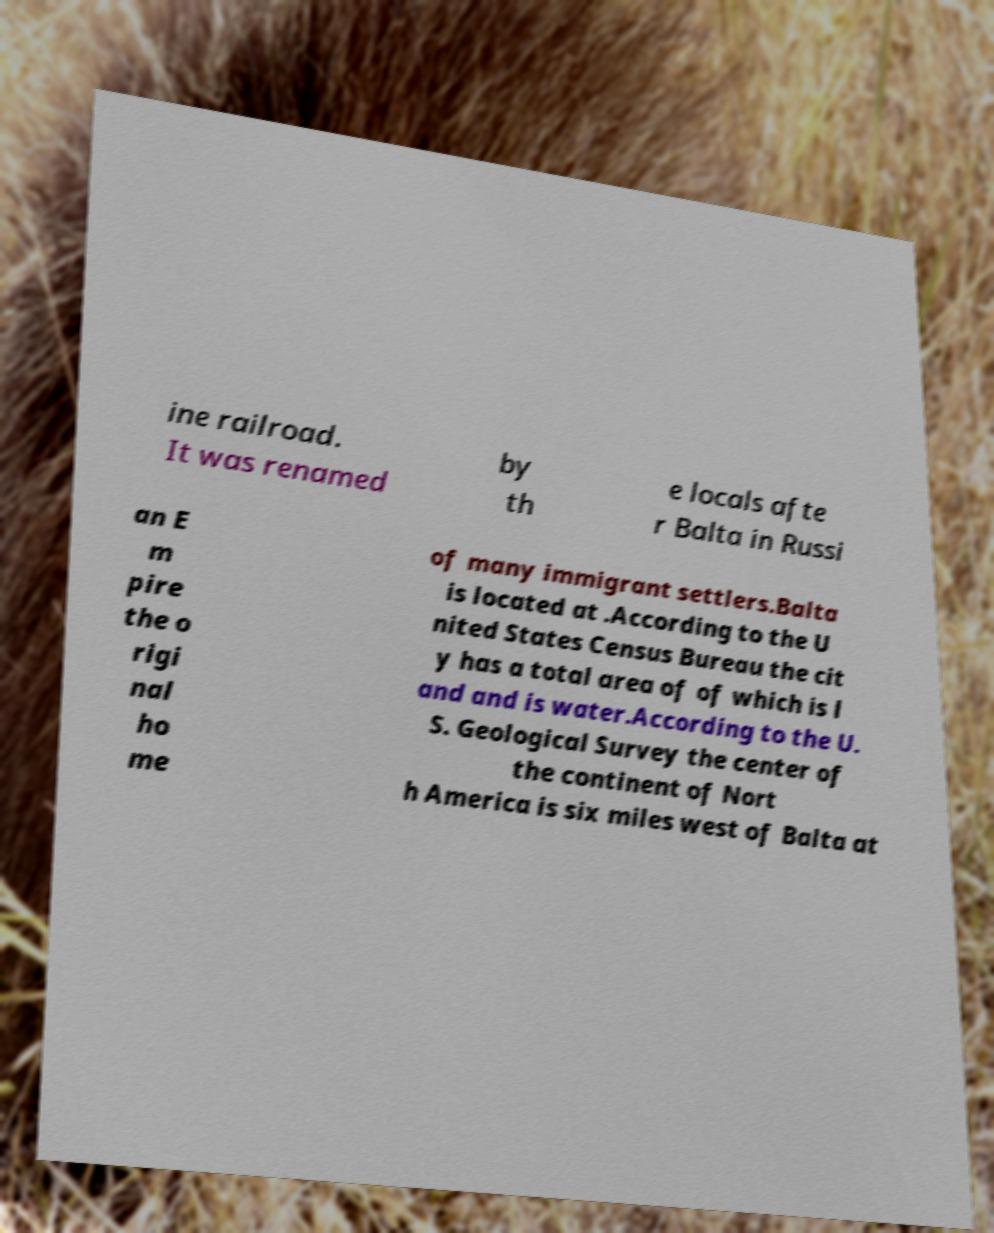Please identify and transcribe the text found in this image. ine railroad. It was renamed by th e locals afte r Balta in Russi an E m pire the o rigi nal ho me of many immigrant settlers.Balta is located at .According to the U nited States Census Bureau the cit y has a total area of of which is l and and is water.According to the U. S. Geological Survey the center of the continent of Nort h America is six miles west of Balta at 